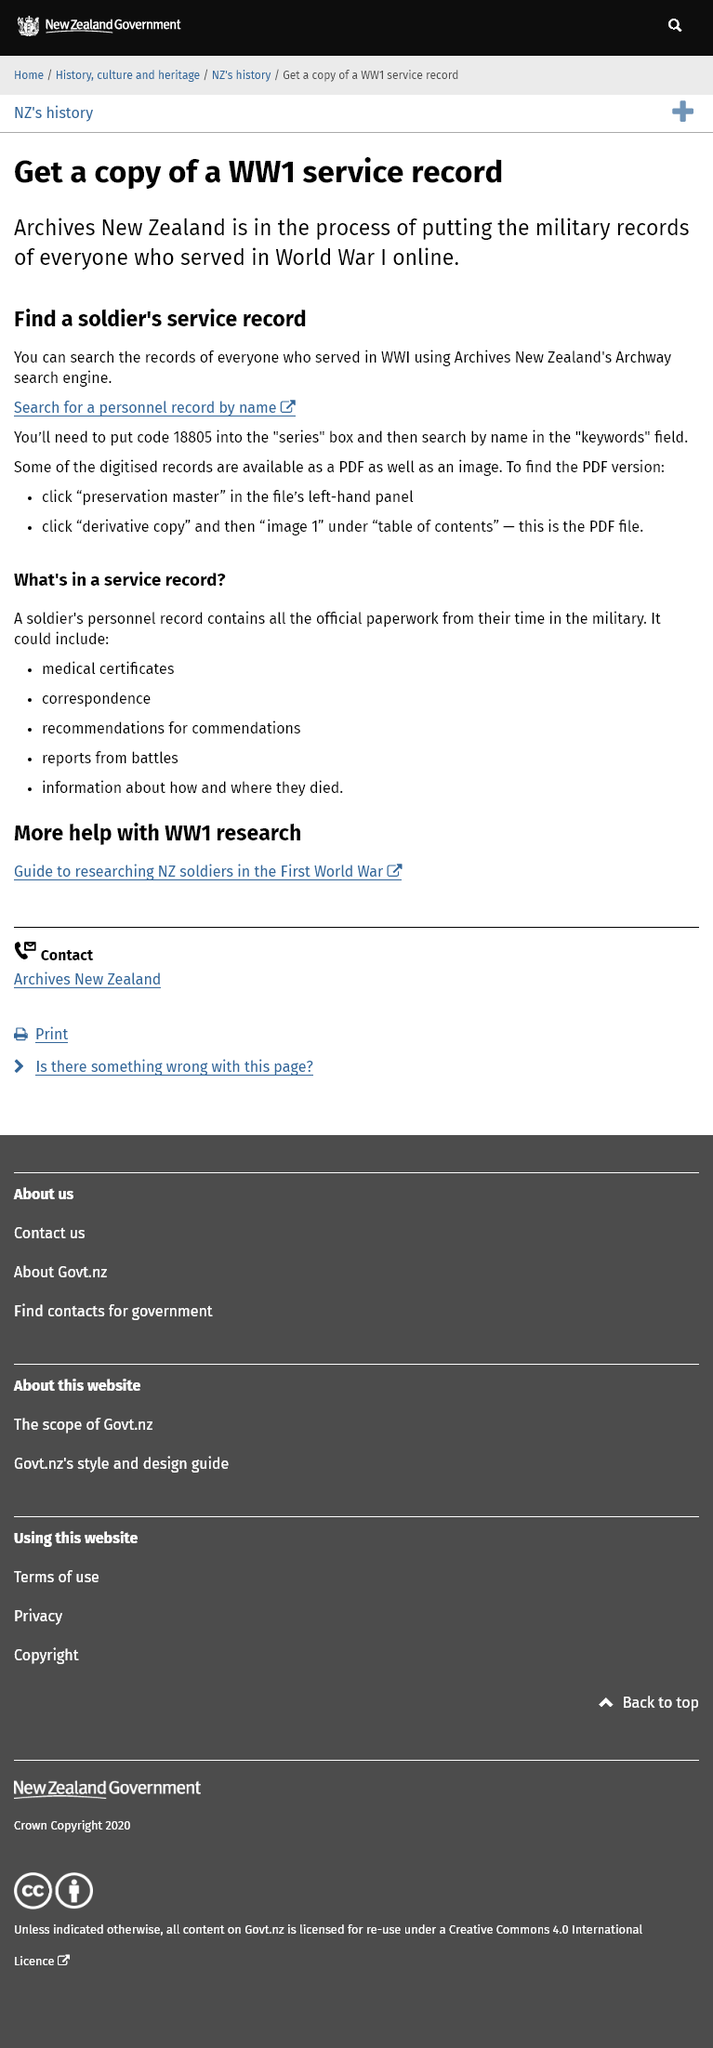Mention a couple of crucial points in this snapshot. You can find the service records of all World War 1 soldiers on the search engine provided by New Zealand's Archway service. You would find digitized records in a PDF file. Archives New Zealand is responsible for making military records accessible to the public by putting them online. 